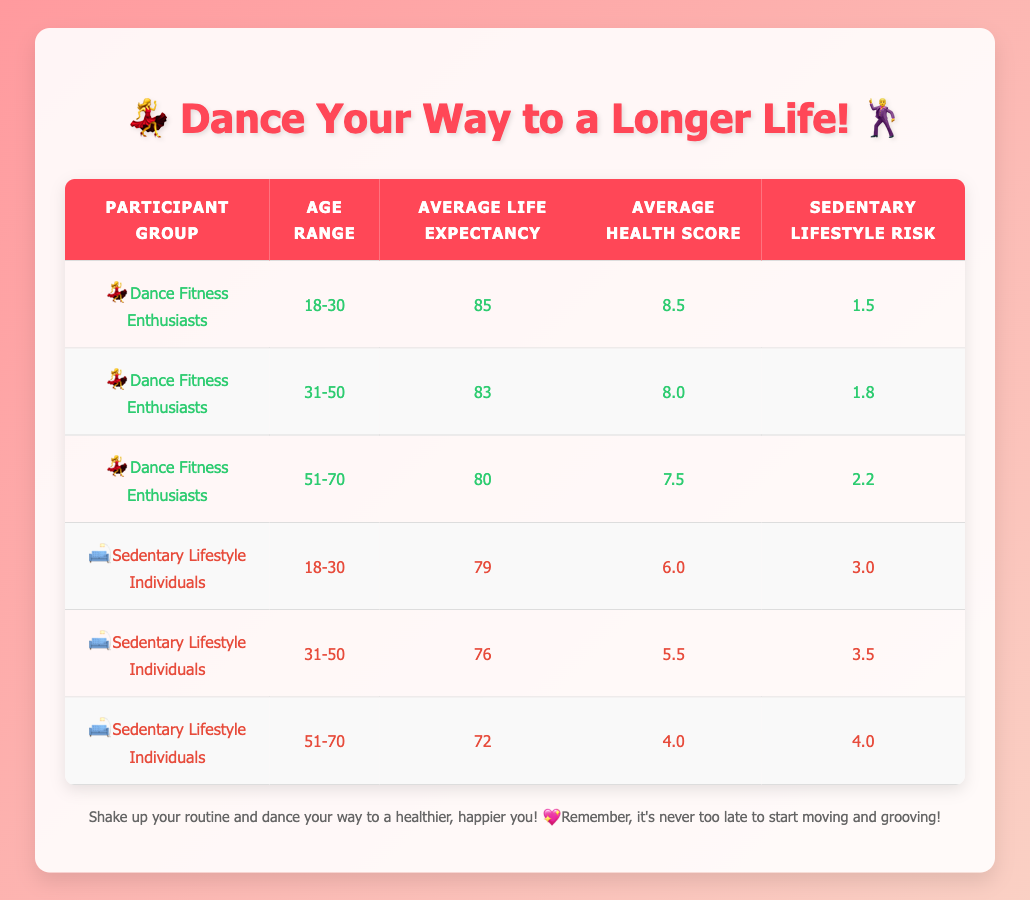What is the average life expectancy of Dance Fitness Enthusiasts aged 31-50? From the table, we can see that for Dance Fitness Enthusiasts in the age range of 31-50, the average life expectancy is stated as 83.
Answer: 83 How much longer do Dance Fitness Enthusiasts aged 18-30 live on average compared to Sedentary Lifestyle Individuals in the same age range? For Dance Fitness Enthusiasts aged 18-30, the average life expectancy is 85, while for Sedentary Lifestyle Individuals in the same age range, it is 79. The difference is 85 - 79 = 6 years.
Answer: 6 years Is the average health score for Sedentary Lifestyle Individuals aged 51-70 higher than 5? The table shows that the average health score for Sedentary Lifestyle Individuals aged 51-70 is 4.0, which is not higher than 5.
Answer: No What is the average life expectancy for individuals who follow a Sedentary Lifestyle across all age ranges combined? To find the average life expectancy for Sedentary Lifestyle Individuals, we take the average of the life expectancies: (79 + 76 + 72) / 3 = 75.67. Thus, we round it to 76 to express it in whole numbers.
Answer: 76 How does the sedentary lifestyle risk change with age for Dance Fitness Enthusiasts? For Dance Fitness Enthusiasts, the sedentary lifestyle risk increases with age: 1.5 (18-30), 1.8 (31-50), and 2.2 (51-70). This shows a steady increase as the age range goes up.
Answer: Increases How much higher is the average health score for Dance Fitness Enthusiasts aged 18-30 compared to their counterparts with a Sedentary Lifestyle? The average health score for Dance Fitness Enthusiasts aged 18-30 is 8.5, and for Sedentary Lifestyle Individuals of the same age is 6.0. The difference is 8.5 - 6.0 = 2.5.
Answer: 2.5 Are there any age ranges where the average life expectancy for Dance Fitness Enthusiasts is lower than that for Sedentary Lifestyle Individuals? Looking at the table, all age ranges for Dance Fitness Enthusiasts have a higher average life expectancy than Sedentary Lifestyle Individuals, as 85 > 79, 83 > 76, and 80 > 72.
Answer: No What is the trend of average life expectancy for both groups as age increases? The trend shows that for Dance Fitness Enthusiasts, life expectancy decreases from 85 to 80 as they age. For Sedentary Lifestyle Individuals, the average life expectancy also decreases from 79 to 72. Both groups show a downward trend with aging.
Answer: Decreases for both groups 